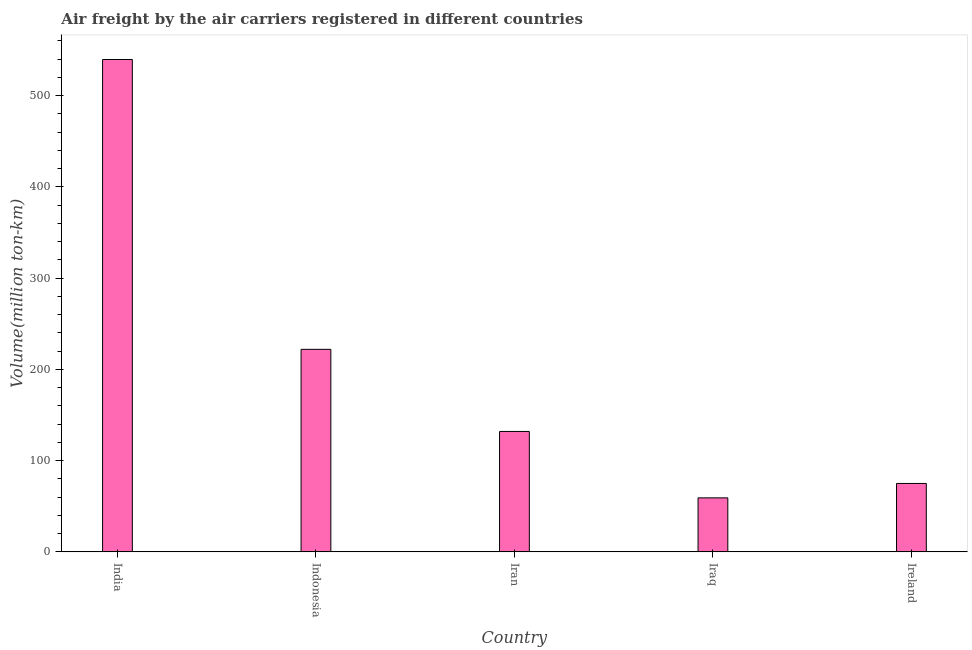What is the title of the graph?
Provide a succinct answer. Air freight by the air carriers registered in different countries. What is the label or title of the X-axis?
Ensure brevity in your answer.  Country. What is the label or title of the Y-axis?
Ensure brevity in your answer.  Volume(million ton-km). What is the air freight in Iraq?
Your response must be concise. 59.2. Across all countries, what is the maximum air freight?
Ensure brevity in your answer.  539.7. Across all countries, what is the minimum air freight?
Offer a very short reply. 59.2. In which country was the air freight minimum?
Give a very brief answer. Iraq. What is the sum of the air freight?
Your answer should be compact. 1027.9. What is the difference between the air freight in Indonesia and Iran?
Make the answer very short. 90. What is the average air freight per country?
Make the answer very short. 205.58. What is the median air freight?
Keep it short and to the point. 132. What is the ratio of the air freight in Iraq to that in Ireland?
Keep it short and to the point. 0.79. Is the difference between the air freight in Indonesia and Iraq greater than the difference between any two countries?
Provide a succinct answer. No. What is the difference between the highest and the second highest air freight?
Your response must be concise. 317.7. Is the sum of the air freight in Iran and Iraq greater than the maximum air freight across all countries?
Provide a short and direct response. No. What is the difference between the highest and the lowest air freight?
Offer a terse response. 480.5. How many countries are there in the graph?
Your answer should be very brief. 5. Are the values on the major ticks of Y-axis written in scientific E-notation?
Ensure brevity in your answer.  No. What is the Volume(million ton-km) in India?
Keep it short and to the point. 539.7. What is the Volume(million ton-km) in Indonesia?
Your answer should be very brief. 222. What is the Volume(million ton-km) of Iran?
Give a very brief answer. 132. What is the Volume(million ton-km) of Iraq?
Make the answer very short. 59.2. What is the difference between the Volume(million ton-km) in India and Indonesia?
Provide a succinct answer. 317.7. What is the difference between the Volume(million ton-km) in India and Iran?
Your response must be concise. 407.7. What is the difference between the Volume(million ton-km) in India and Iraq?
Give a very brief answer. 480.5. What is the difference between the Volume(million ton-km) in India and Ireland?
Give a very brief answer. 464.7. What is the difference between the Volume(million ton-km) in Indonesia and Iraq?
Ensure brevity in your answer.  162.8. What is the difference between the Volume(million ton-km) in Indonesia and Ireland?
Ensure brevity in your answer.  147. What is the difference between the Volume(million ton-km) in Iran and Iraq?
Ensure brevity in your answer.  72.8. What is the difference between the Volume(million ton-km) in Iraq and Ireland?
Offer a very short reply. -15.8. What is the ratio of the Volume(million ton-km) in India to that in Indonesia?
Offer a terse response. 2.43. What is the ratio of the Volume(million ton-km) in India to that in Iran?
Offer a very short reply. 4.09. What is the ratio of the Volume(million ton-km) in India to that in Iraq?
Offer a very short reply. 9.12. What is the ratio of the Volume(million ton-km) in India to that in Ireland?
Ensure brevity in your answer.  7.2. What is the ratio of the Volume(million ton-km) in Indonesia to that in Iran?
Give a very brief answer. 1.68. What is the ratio of the Volume(million ton-km) in Indonesia to that in Iraq?
Your answer should be very brief. 3.75. What is the ratio of the Volume(million ton-km) in Indonesia to that in Ireland?
Give a very brief answer. 2.96. What is the ratio of the Volume(million ton-km) in Iran to that in Iraq?
Offer a very short reply. 2.23. What is the ratio of the Volume(million ton-km) in Iran to that in Ireland?
Make the answer very short. 1.76. What is the ratio of the Volume(million ton-km) in Iraq to that in Ireland?
Ensure brevity in your answer.  0.79. 